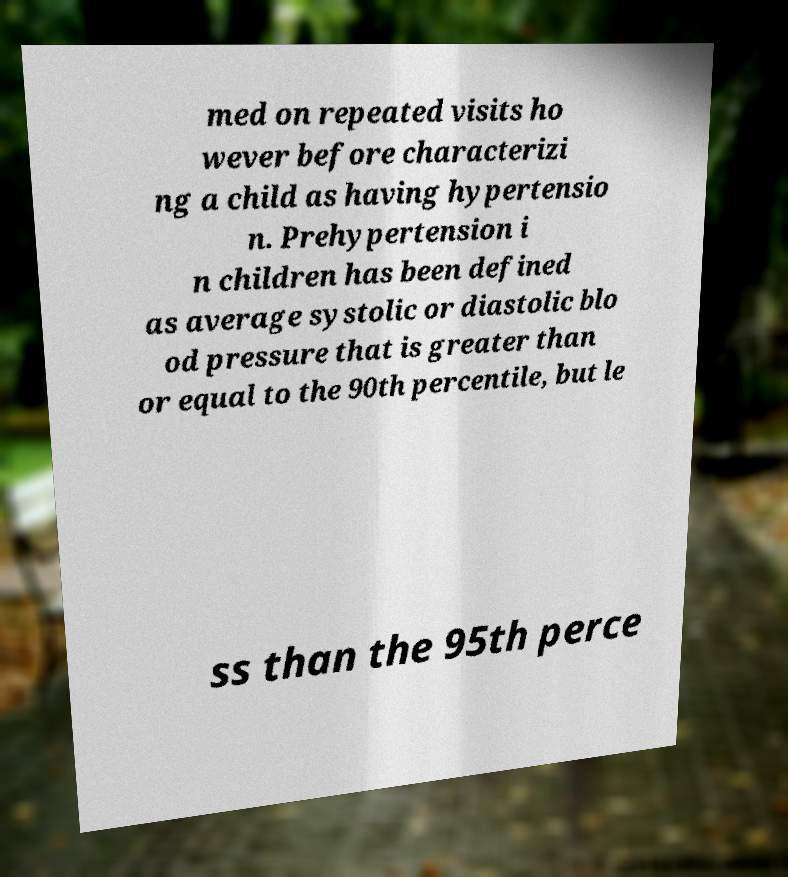For documentation purposes, I need the text within this image transcribed. Could you provide that? med on repeated visits ho wever before characterizi ng a child as having hypertensio n. Prehypertension i n children has been defined as average systolic or diastolic blo od pressure that is greater than or equal to the 90th percentile, but le ss than the 95th perce 